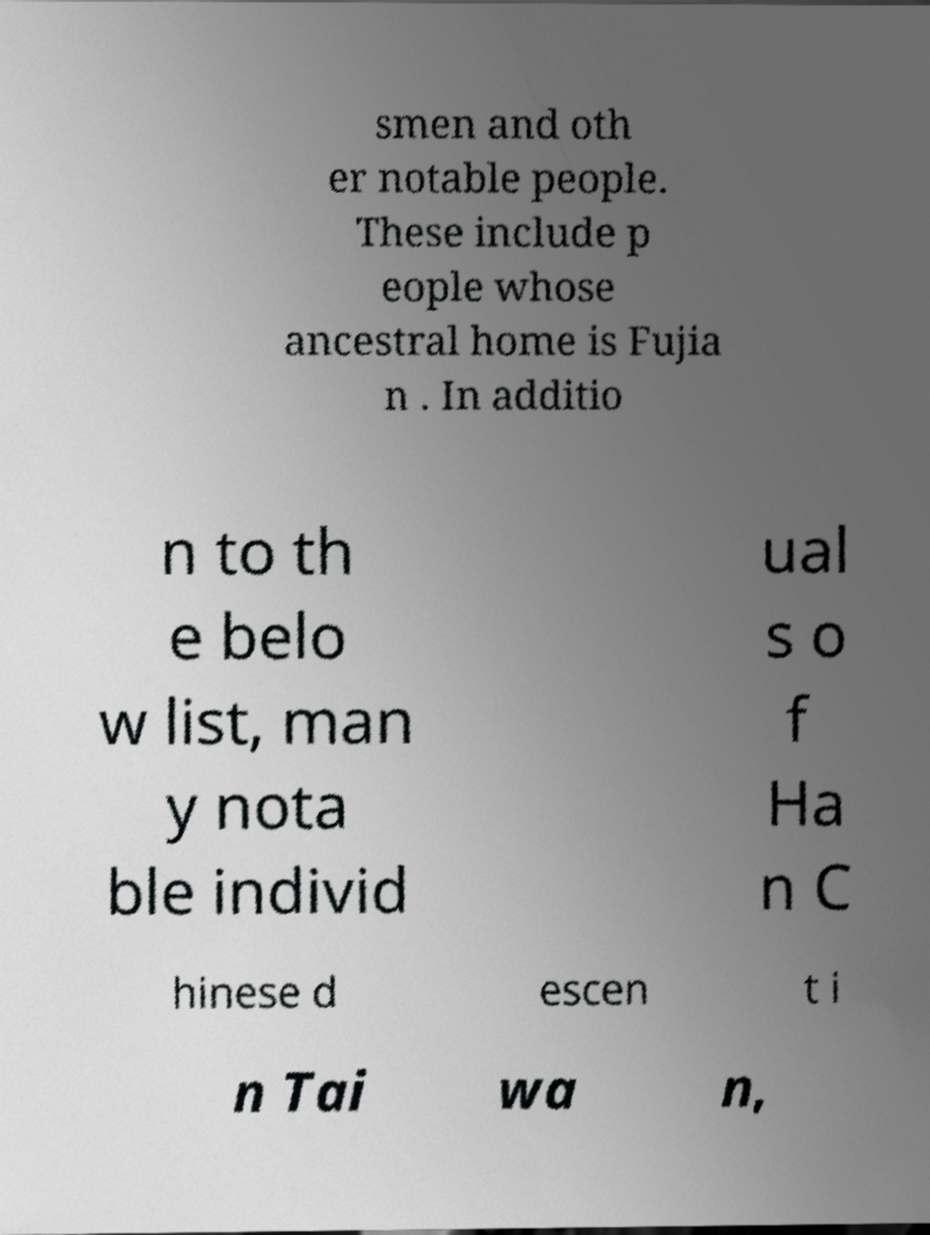There's text embedded in this image that I need extracted. Can you transcribe it verbatim? smen and oth er notable people. These include p eople whose ancestral home is Fujia n . In additio n to th e belo w list, man y nota ble individ ual s o f Ha n C hinese d escen t i n Tai wa n, 